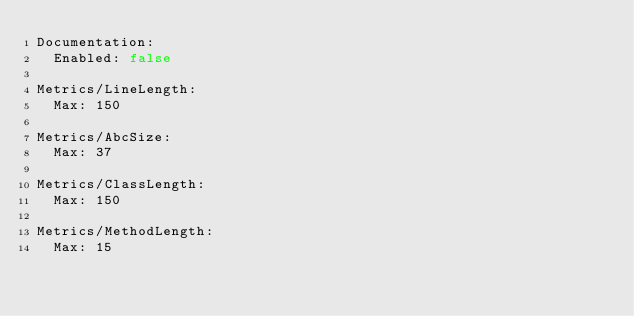Convert code to text. <code><loc_0><loc_0><loc_500><loc_500><_YAML_>Documentation:
  Enabled: false

Metrics/LineLength:
  Max: 150

Metrics/AbcSize:
  Max: 37

Metrics/ClassLength:
  Max: 150

Metrics/MethodLength:
  Max: 15
</code> 